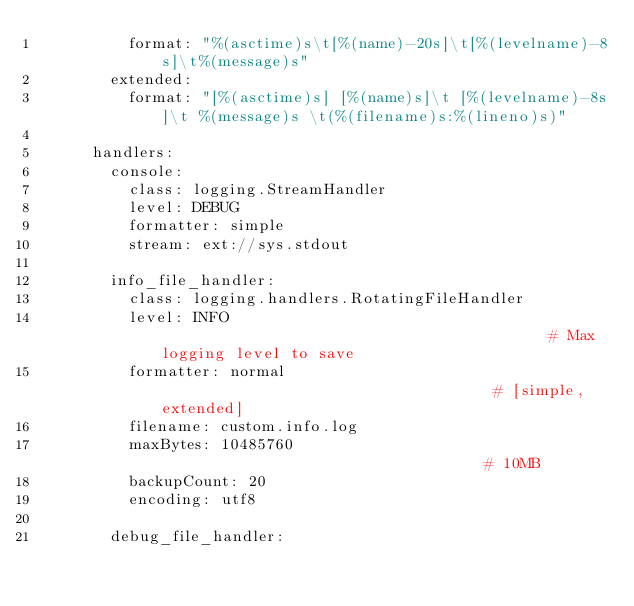<code> <loc_0><loc_0><loc_500><loc_500><_YAML_>          format: "%(asctime)s\t[%(name)-20s]\t[%(levelname)-8s]\t%(message)s"
        extended:
          format: "[%(asctime)s] [%(name)s]\t [%(levelname)-8s]\t %(message)s \t(%(filename)s:%(lineno)s)"

      handlers:
        console:
          class: logging.StreamHandler
          level: DEBUG
          formatter: simple
          stream: ext://sys.stdout

        info_file_handler:
          class: logging.handlers.RotatingFileHandler
          level: INFO                                           # Max logging level to save
          formatter: normal                                     # [simple, extended]
          filename: custom.info.log
          maxBytes: 10485760                                    # 10MB
          backupCount: 20
          encoding: utf8

        debug_file_handler:</code> 